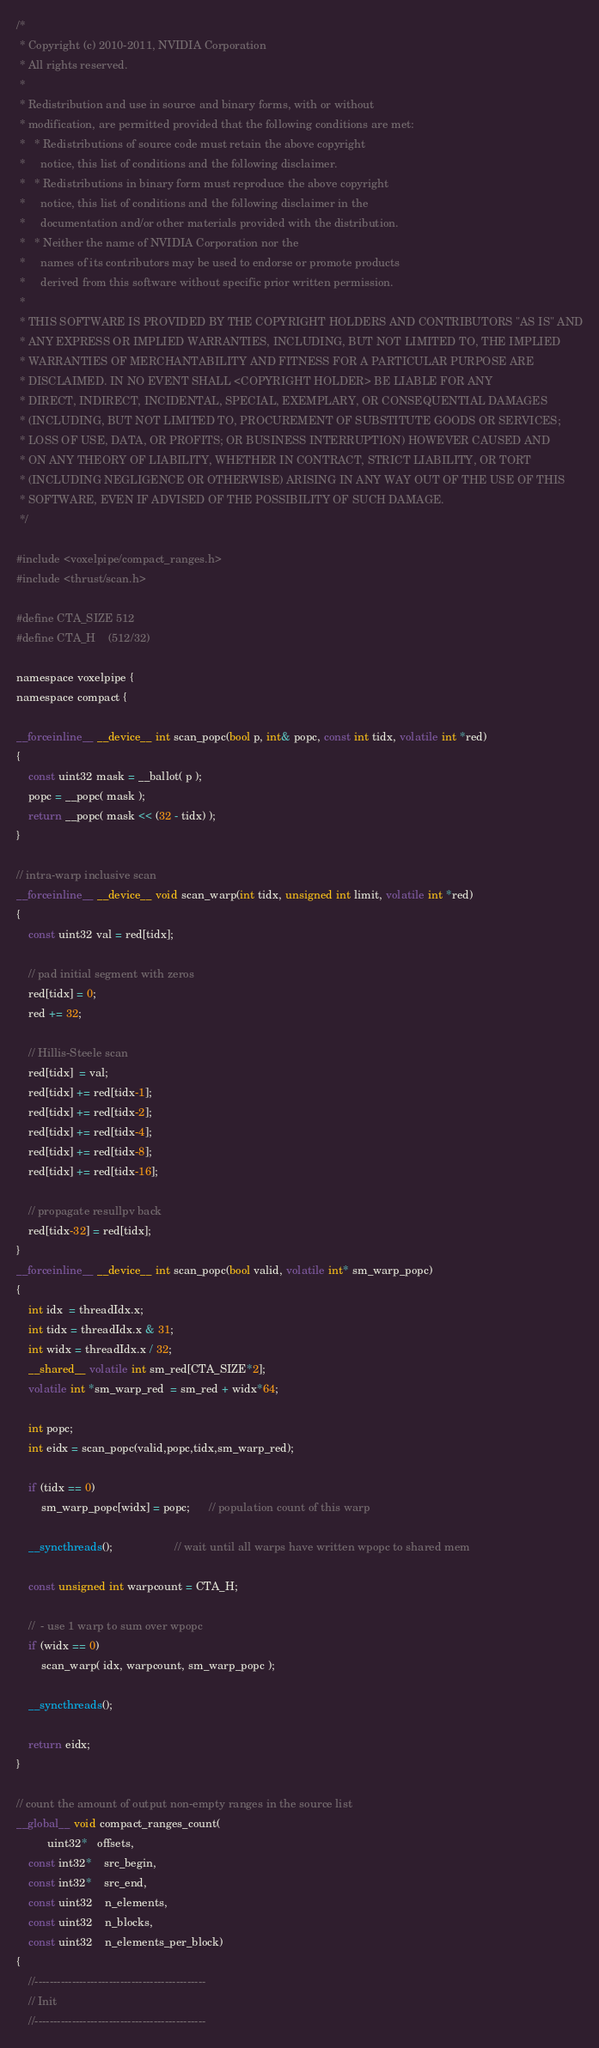<code> <loc_0><loc_0><loc_500><loc_500><_Cuda_>/*
 * Copyright (c) 2010-2011, NVIDIA Corporation
 * All rights reserved.
 *
 * Redistribution and use in source and binary forms, with or without
 * modification, are permitted provided that the following conditions are met:
 *   * Redistributions of source code must retain the above copyright
 *     notice, this list of conditions and the following disclaimer.
 *   * Redistributions in binary form must reproduce the above copyright
 *     notice, this list of conditions and the following disclaimer in the
 *     documentation and/or other materials provided with the distribution.
 *   * Neither the name of NVIDIA Corporation nor the
 *     names of its contributors may be used to endorse or promote products
 *     derived from this software without specific prior written permission.
 *
 * THIS SOFTWARE IS PROVIDED BY THE COPYRIGHT HOLDERS AND CONTRIBUTORS "AS IS" AND
 * ANY EXPRESS OR IMPLIED WARRANTIES, INCLUDING, BUT NOT LIMITED TO, THE IMPLIED
 * WARRANTIES OF MERCHANTABILITY AND FITNESS FOR A PARTICULAR PURPOSE ARE
 * DISCLAIMED. IN NO EVENT SHALL <COPYRIGHT HOLDER> BE LIABLE FOR ANY
 * DIRECT, INDIRECT, INCIDENTAL, SPECIAL, EXEMPLARY, OR CONSEQUENTIAL DAMAGES
 * (INCLUDING, BUT NOT LIMITED TO, PROCUREMENT OF SUBSTITUTE GOODS OR SERVICES;
 * LOSS OF USE, DATA, OR PROFITS; OR BUSINESS INTERRUPTION) HOWEVER CAUSED AND
 * ON ANY THEORY OF LIABILITY, WHETHER IN CONTRACT, STRICT LIABILITY, OR TORT
 * (INCLUDING NEGLIGENCE OR OTHERWISE) ARISING IN ANY WAY OUT OF THE USE OF THIS
 * SOFTWARE, EVEN IF ADVISED OF THE POSSIBILITY OF SUCH DAMAGE.
 */

#include <voxelpipe/compact_ranges.h>
#include <thrust/scan.h>

#define CTA_SIZE 512
#define CTA_H    (512/32)

namespace voxelpipe {
namespace compact {

__forceinline__ __device__ int scan_popc(bool p, int& popc, const int tidx, volatile int *red)
{
    const uint32 mask = __ballot( p );
    popc = __popc( mask );
    return __popc( mask << (32 - tidx) );
}

// intra-warp inclusive scan
__forceinline__ __device__ void scan_warp(int tidx, unsigned int limit, volatile int *red)
{
    const uint32 val = red[tidx];

    // pad initial segment with zeros
    red[tidx] = 0;
    red += 32;

    // Hillis-Steele scan
    red[tidx]  = val;
    red[tidx] += red[tidx-1];
    red[tidx] += red[tidx-2];
    red[tidx] += red[tidx-4];
    red[tidx] += red[tidx-8];
    red[tidx] += red[tidx-16];

    // propagate resullpv back
    red[tidx-32] = red[tidx];
}
__forceinline__ __device__ int scan_popc(bool valid, volatile int* sm_warp_popc)
{
    int idx  = threadIdx.x;
	int tidx = threadIdx.x & 31;
	int widx = threadIdx.x / 32;
	__shared__ volatile int sm_red[CTA_SIZE*2];
	volatile int *sm_warp_red  = sm_red + widx*64;

    int popc;
	int eidx = scan_popc(valid,popc,tidx,sm_warp_red);

    if (tidx == 0)
    	sm_warp_popc[widx] = popc;      // population count of this warp

	__syncthreads();					// wait until all warps have written wpopc to shared mem

    const unsigned int warpcount = CTA_H;

    //  - use 1 warp to sum over wpopc
    if (widx == 0)
        scan_warp( idx, warpcount, sm_warp_popc );

    __syncthreads();

    return eidx;
}

// count the amount of output non-empty ranges in the source list
__global__ void compact_ranges_count(
          uint32*   offsets,
    const int32*    src_begin,
    const int32*    src_end,
    const uint32    n_elements,
    const uint32    n_blocks,
    const uint32    n_elements_per_block)
{
	//----------------------------------------------
	// Init
	//----------------------------------------------
</code> 